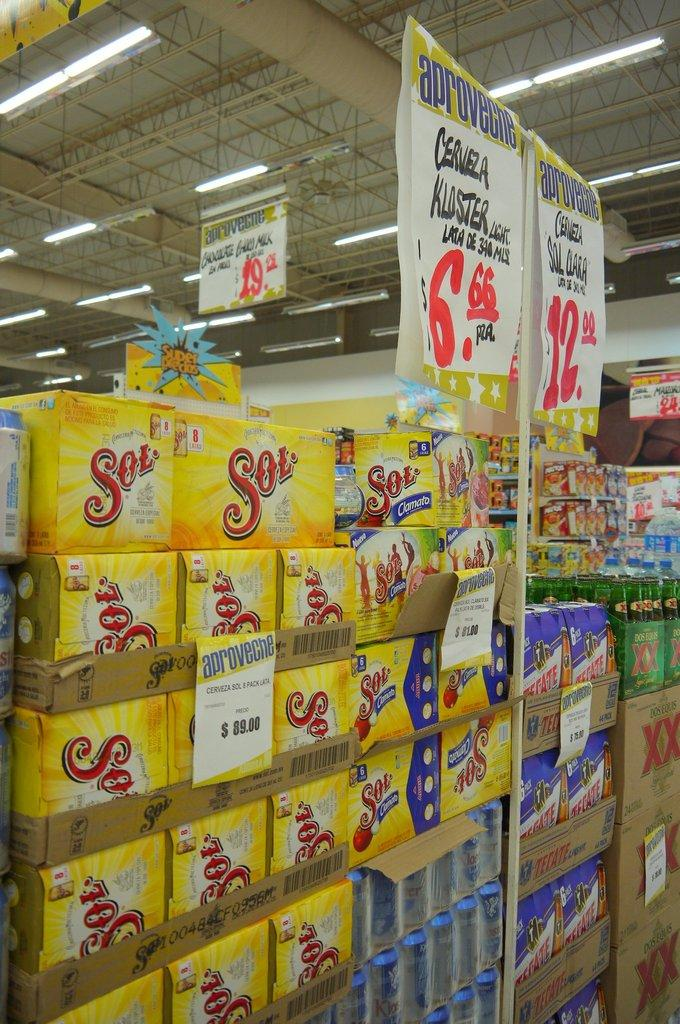<image>
Share a concise interpretation of the image provided. a word Sol that is on many different products 